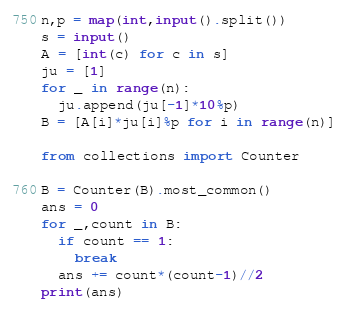<code> <loc_0><loc_0><loc_500><loc_500><_Python_>n,p = map(int,input().split())
s = input()
A = [int(c) for c in s]
ju = [1]
for _ in range(n):
  ju.append(ju[-1]*10%p)
B = [A[i]*ju[i]%p for i in range(n)]

from collections import Counter

B = Counter(B).most_common()
ans = 0
for _,count in B:
  if count == 1:
    break
  ans += count*(count-1)//2
print(ans)</code> 